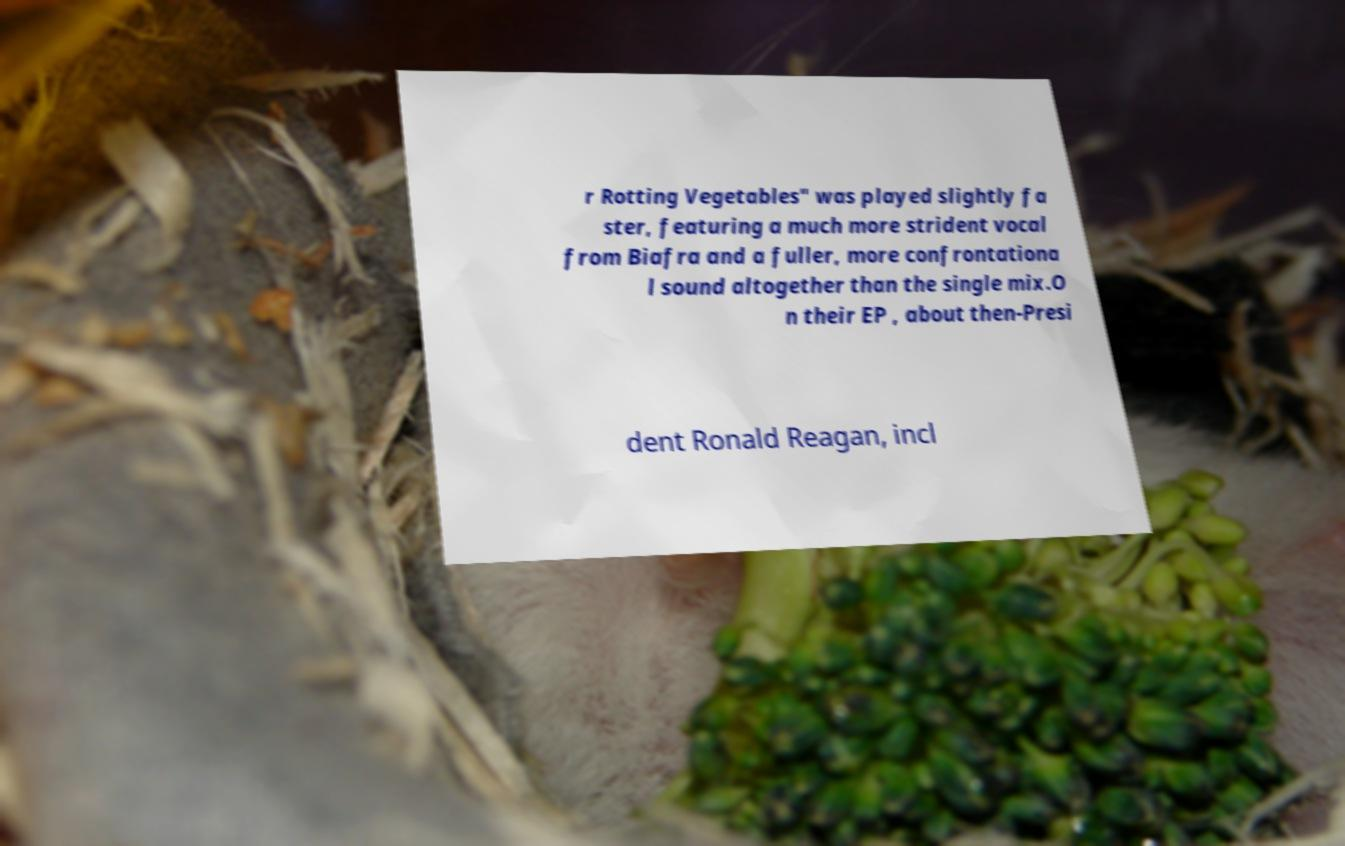For documentation purposes, I need the text within this image transcribed. Could you provide that? r Rotting Vegetables" was played slightly fa ster, featuring a much more strident vocal from Biafra and a fuller, more confrontationa l sound altogether than the single mix.O n their EP , about then-Presi dent Ronald Reagan, incl 